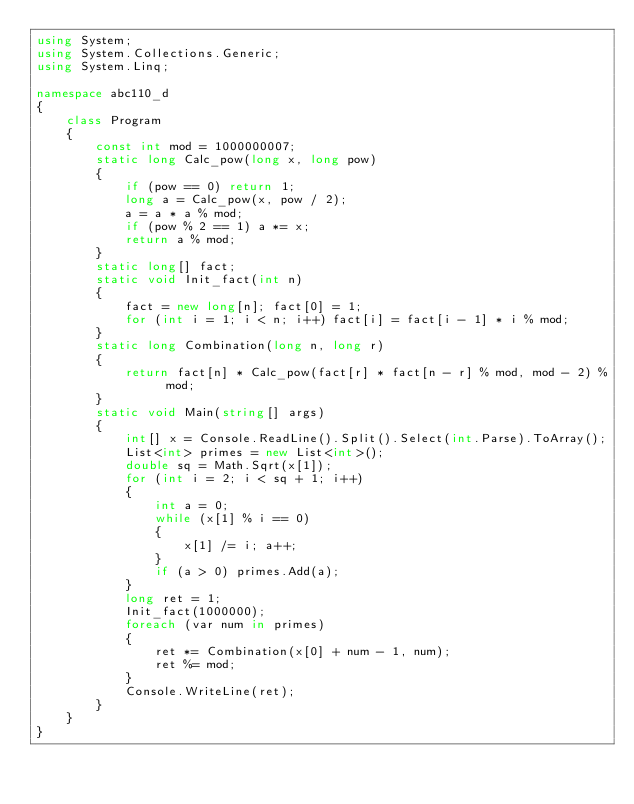Convert code to text. <code><loc_0><loc_0><loc_500><loc_500><_C#_>using System;
using System.Collections.Generic;
using System.Linq;

namespace abc110_d
{
	class Program
	{
		const int mod = 1000000007;
		static long Calc_pow(long x, long pow)
		{
			if (pow == 0) return 1;
			long a = Calc_pow(x, pow / 2);
			a = a * a % mod;
			if (pow % 2 == 1) a *= x;
			return a % mod;
		}
		static long[] fact;
		static void Init_fact(int n)
		{
			fact = new long[n]; fact[0] = 1;
			for (int i = 1; i < n; i++) fact[i] = fact[i - 1] * i % mod;
		}
		static long Combination(long n, long r)
		{
			return fact[n] * Calc_pow(fact[r] * fact[n - r] % mod, mod - 2) % mod;
		}
		static void Main(string[] args)
		{
			int[] x = Console.ReadLine().Split().Select(int.Parse).ToArray();
			List<int> primes = new List<int>();
			double sq = Math.Sqrt(x[1]);
			for (int i = 2; i < sq + 1; i++)
			{
				int a = 0;
				while (x[1] % i == 0)
				{
					x[1] /= i; a++;
				}
				if (a > 0) primes.Add(a);
			}
			long ret = 1;
			Init_fact(1000000);
			foreach (var num in primes)
			{
				ret *= Combination(x[0] + num - 1, num);
				ret %= mod;
			}
			Console.WriteLine(ret);
		}
	}
}</code> 